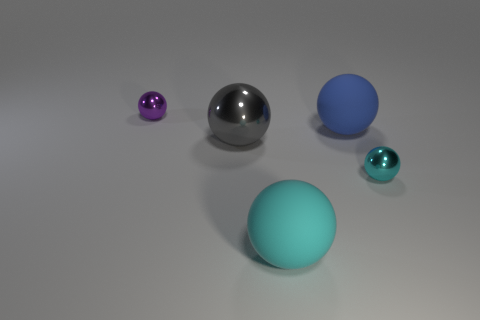The big thing that is the same material as the small purple ball is what shape?
Provide a short and direct response. Sphere. Is there any other thing that has the same color as the large metal ball?
Your answer should be compact. No. The small object left of the large gray shiny sphere is what color?
Keep it short and to the point. Purple. Does the metal sphere that is behind the large blue rubber object have the same color as the large metallic sphere?
Ensure brevity in your answer.  No. There is a blue object that is the same shape as the gray thing; what material is it?
Give a very brief answer. Rubber. What number of gray metallic balls are the same size as the purple sphere?
Ensure brevity in your answer.  0. What is the shape of the tiny cyan shiny object?
Your response must be concise. Sphere. There is a thing that is right of the gray metal sphere and to the left of the blue rubber object; how big is it?
Ensure brevity in your answer.  Large. There is a small ball in front of the purple shiny sphere; what material is it?
Make the answer very short. Metal. Do the large metal ball and the large rubber thing that is behind the gray shiny object have the same color?
Give a very brief answer. No. 